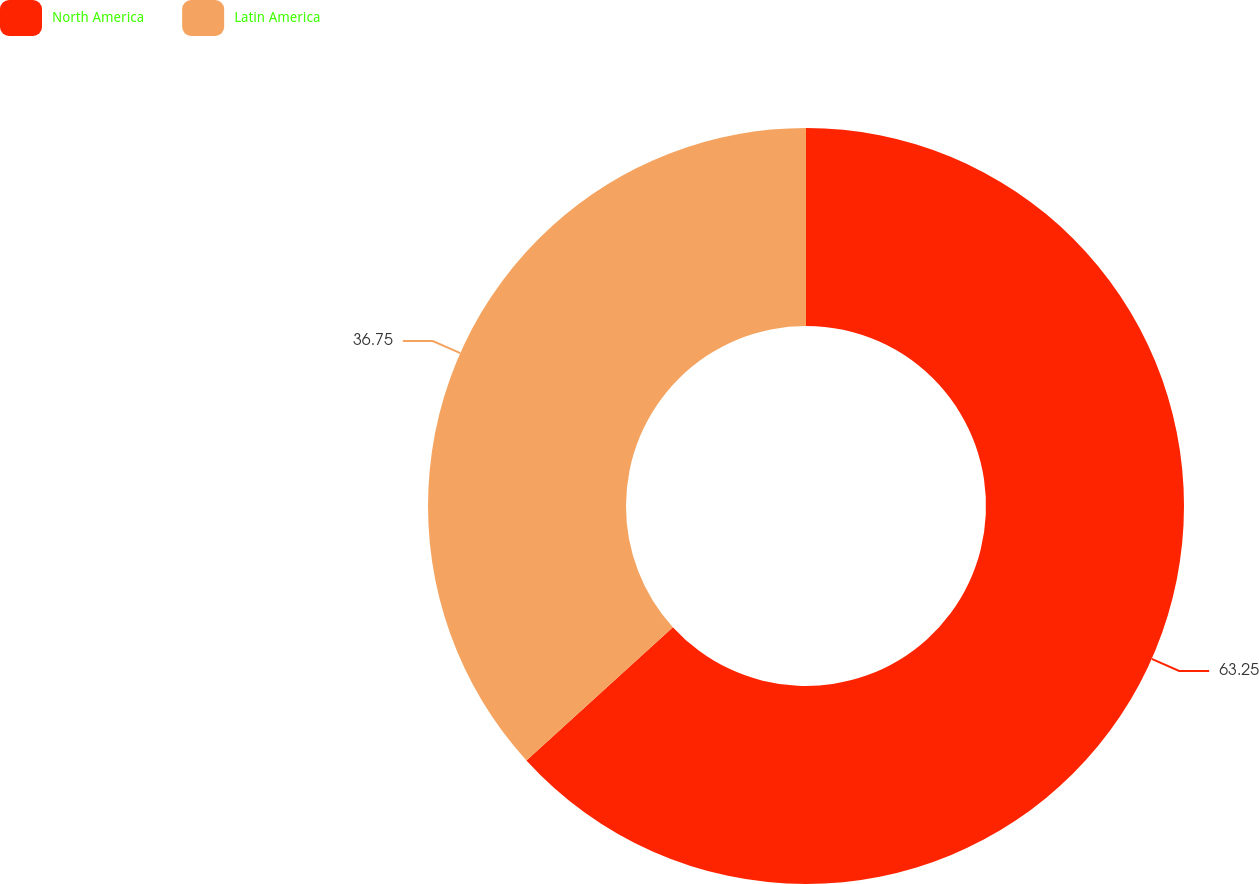<chart> <loc_0><loc_0><loc_500><loc_500><pie_chart><fcel>North America<fcel>Latin America<nl><fcel>63.25%<fcel>36.75%<nl></chart> 